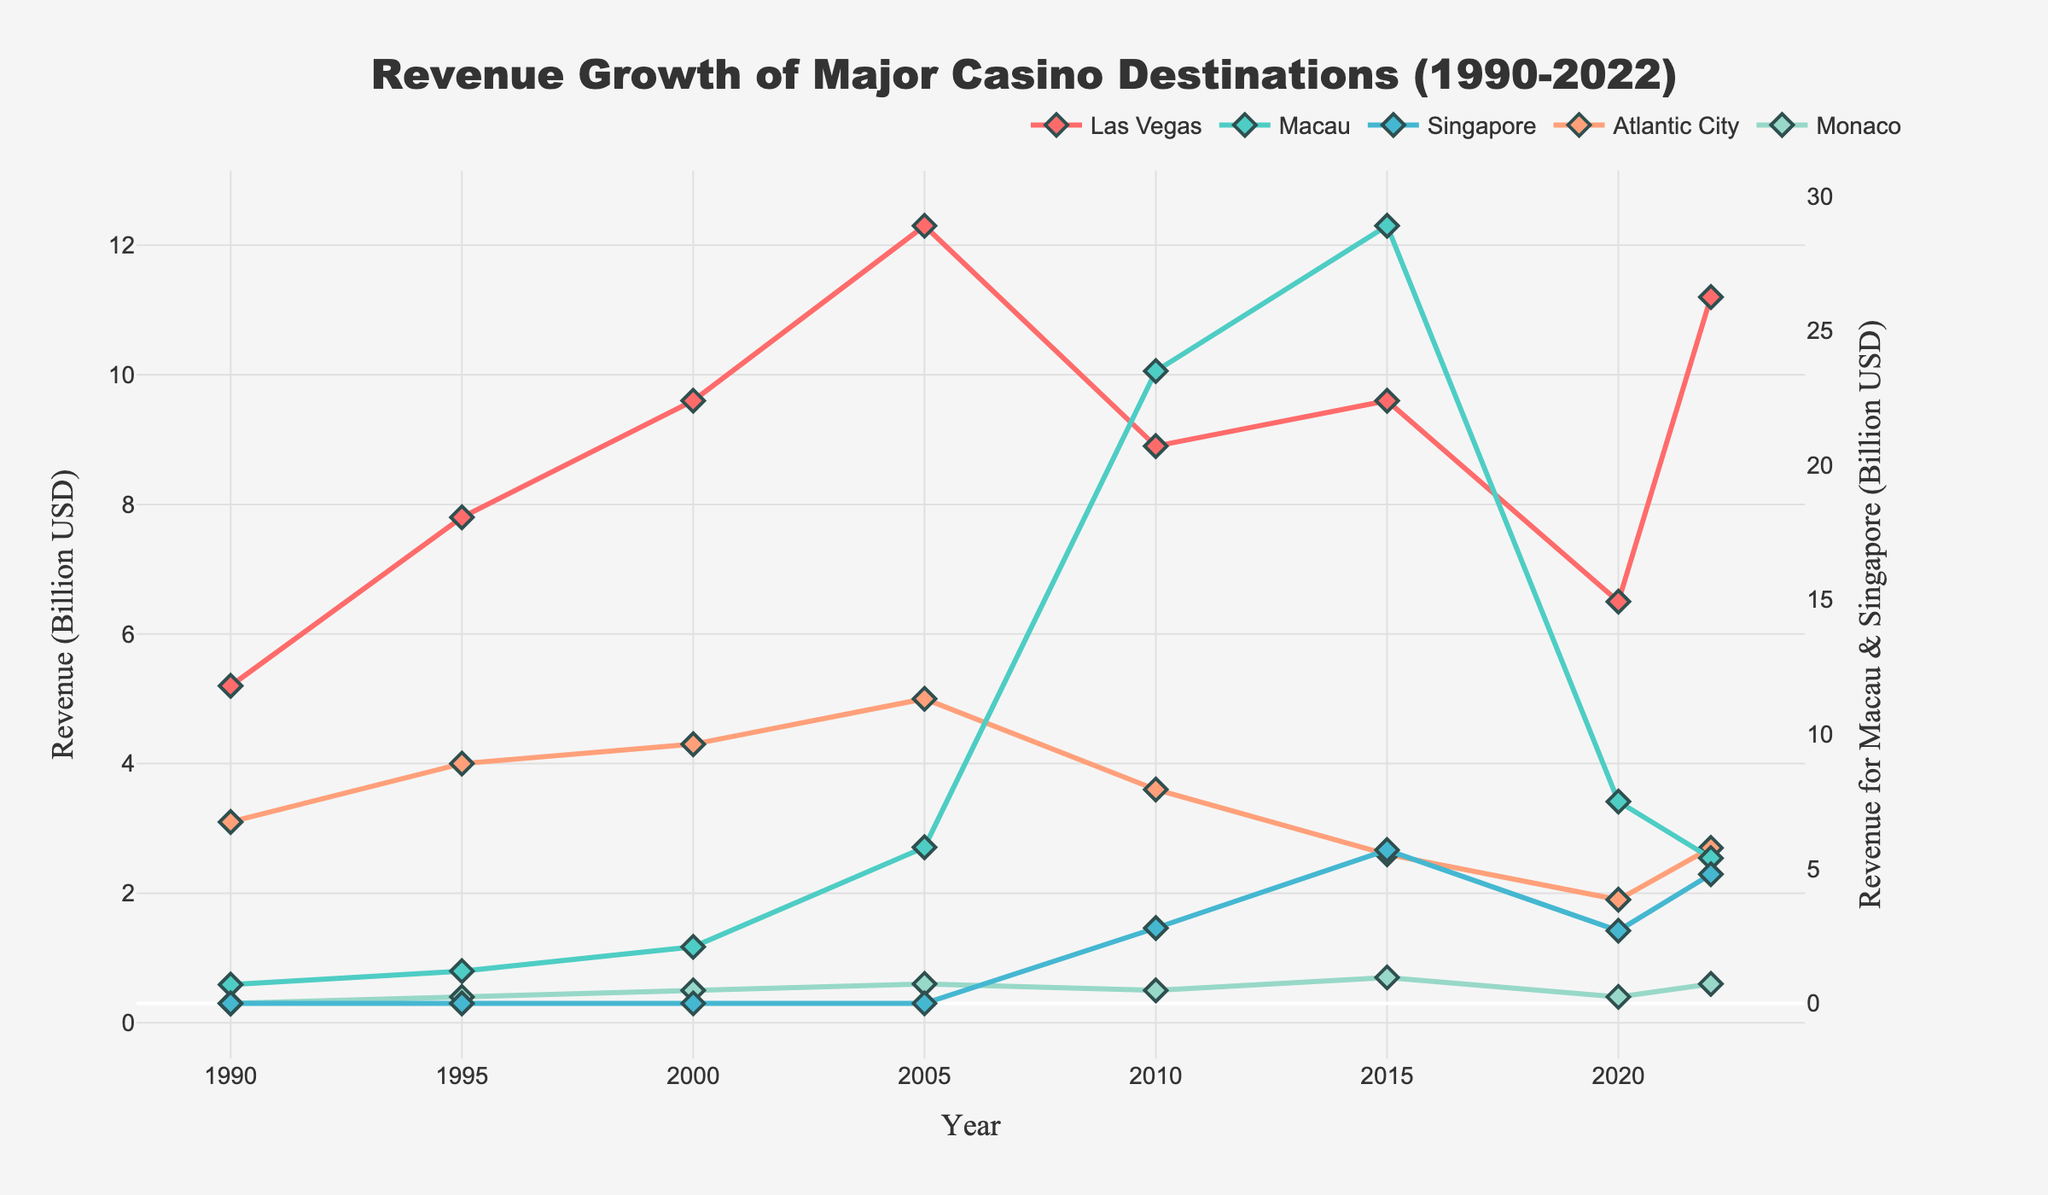What's the highest revenue recorded by Macau? By examining the line representing Macau on the chart, we can see that the peak revenue is in 2015, where it reaches the highest point on the y-axis for this destination. The y-axis value is 28.9 billion USD.
Answer: 28.9 billion USD How did the revenue of Las Vegas change from 2000 to 2010? Observing the graph, Las Vegas had a revenue of 9.6 billion USD in 2000. By 2010, the line for Las Vegas is at 8.9 billion USD. Therefore, the revenue decreased from 9.6 billion USD to 8.9 billion USD over this period.
Answer: Decreased by 0.7 billion USD Which casino destination had the least revenue in 2020, and how much was it? Looking at the points on the graph for the year 2020, Monaco has the lowest position, indicating the smallest revenue. The y-axis value for Monaco in 2020 is 0.4 billion USD.
Answer: Monaco, 0.4 billion USD Compare the revenue growth between Singapore and Atlantic City from 2010 to 2015. Singapore's revenue increased from 2.8 billion USD in 2010 to 5.7 billion USD in 2015 (an increase of 2.9 billion USD). Atlantic City's revenue decreased from 3.6 billion USD in 2010 to 2.6 billion USD in 2015 (a decrease of 1 billion USD).
Answer: Singapore increased by 2.9 billion USD, Atlantic City decreased by 1 billion USD How does the 2020 revenue of Singapore compare to its 2015 revenue? Referring to the graph, Singapore's revenue is 5.7 billion USD in 2015 and 2.7 billion USD in 2020. To compare, we subtract 2.7 from 5.7, resulting in a difference of -3 billion USD.
Answer: Decreased by 3 billion USD What is the average revenue of Las Vegas from 1990 to 2022? To get the average, sum the revenues of Las Vegas from 1990 (5.2), 1995 (7.8), 2000 (9.6), 2005 (12.3), 2010 (8.9), 2015 (9.6), 2020 (6.5), and 2022 (11.2). This adds up to 71.1 billion USD. Dividing by 8 (number of data points) gives us an average revenue of 8.8875 billion USD.
Answer: 8.9 billion USD In what year did Las Vegas have the highest revenue, and what was it? Examining the graph, the highest peak for Las Vegas is in 2005, where the line reaches its topmost point. The y-axis value at this point is approximately 12.3 billion USD.
Answer: 2005, 12.3 billion USD What trend can be observed for Macau's revenue from 1990 to 2022? By following the line for Macau through the years, we see a steady increase from 1990 to 2015, peaking at 28.9 billion USD. However, from 2015 onwards, there's a sharp decline to 7.5 billion USD by 2020 and a further decrease to 5.4 billion USD by 2022.
Answer: Increase, then significant decrease How much more revenue did Las Vegas generate than Monaco in 2022? In 2022, Las Vegas’ revenue was 11.2 billion USD, and Monaco's was 0.6 billion USD. Subtracting Monaco's revenue from Las Vegas’s (11.2 - 0.6) results in a difference of 10.6 billion USD.
Answer: 10.6 billion USD 